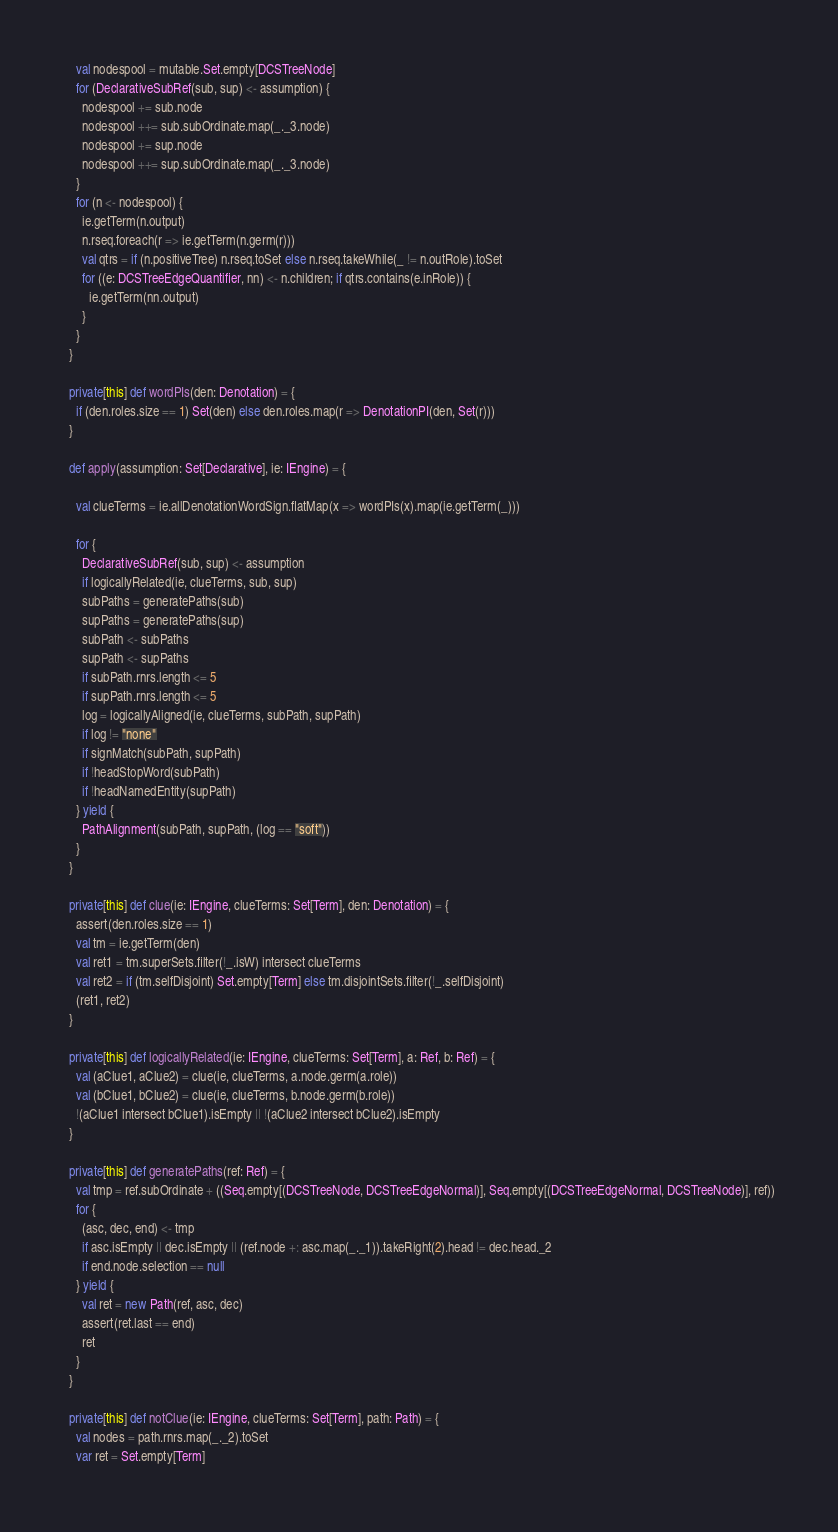Convert code to text. <code><loc_0><loc_0><loc_500><loc_500><_Scala_>    val nodespool = mutable.Set.empty[DCSTreeNode]
    for (DeclarativeSubRef(sub, sup) <- assumption) {
      nodespool += sub.node
      nodespool ++= sub.subOrdinate.map(_._3.node)
      nodespool += sup.node
      nodespool ++= sup.subOrdinate.map(_._3.node)
    }
    for (n <- nodespool) {
      ie.getTerm(n.output)
      n.rseq.foreach(r => ie.getTerm(n.germ(r)))
      val qtrs = if (n.positiveTree) n.rseq.toSet else n.rseq.takeWhile(_ != n.outRole).toSet
      for ((e: DCSTreeEdgeQuantifier, nn) <- n.children; if qtrs.contains(e.inRole)) {
        ie.getTerm(nn.output)
      }
    }
  }

  private[this] def wordPIs(den: Denotation) = {
    if (den.roles.size == 1) Set(den) else den.roles.map(r => DenotationPI(den, Set(r)))
  }

  def apply(assumption: Set[Declarative], ie: IEngine) = {

    val clueTerms = ie.allDenotationWordSign.flatMap(x => wordPIs(x).map(ie.getTerm(_)))

    for {
      DeclarativeSubRef(sub, sup) <- assumption
      if logicallyRelated(ie, clueTerms, sub, sup)
      subPaths = generatePaths(sub)
      supPaths = generatePaths(sup)
      subPath <- subPaths
      supPath <- supPaths
      if subPath.rnrs.length <= 5
      if supPath.rnrs.length <= 5
      log = logicallyAligned(ie, clueTerms, subPath, supPath)
      if log != "none"
      if signMatch(subPath, supPath)
      if !headStopWord(subPath)
      if !headNamedEntity(supPath)
    } yield {
      PathAlignment(subPath, supPath, (log == "soft"))
    }
  }

  private[this] def clue(ie: IEngine, clueTerms: Set[Term], den: Denotation) = {
    assert(den.roles.size == 1)
    val tm = ie.getTerm(den)
    val ret1 = tm.superSets.filter(!_.isW) intersect clueTerms
    val ret2 = if (tm.selfDisjoint) Set.empty[Term] else tm.disjointSets.filter(!_.selfDisjoint)
    (ret1, ret2)
  }

  private[this] def logicallyRelated(ie: IEngine, clueTerms: Set[Term], a: Ref, b: Ref) = {
    val (aClue1, aClue2) = clue(ie, clueTerms, a.node.germ(a.role))
    val (bClue1, bClue2) = clue(ie, clueTerms, b.node.germ(b.role))
    !(aClue1 intersect bClue1).isEmpty || !(aClue2 intersect bClue2).isEmpty
  }

  private[this] def generatePaths(ref: Ref) = {
    val tmp = ref.subOrdinate + ((Seq.empty[(DCSTreeNode, DCSTreeEdgeNormal)], Seq.empty[(DCSTreeEdgeNormal, DCSTreeNode)], ref))
    for {
      (asc, dec, end) <- tmp
      if asc.isEmpty || dec.isEmpty || (ref.node +: asc.map(_._1)).takeRight(2).head != dec.head._2
      if end.node.selection == null
    } yield {
      val ret = new Path(ref, asc, dec)
      assert(ret.last == end)
      ret
    }
  }

  private[this] def notClue(ie: IEngine, clueTerms: Set[Term], path: Path) = {
    val nodes = path.rnrs.map(_._2).toSet
    var ret = Set.empty[Term]</code> 